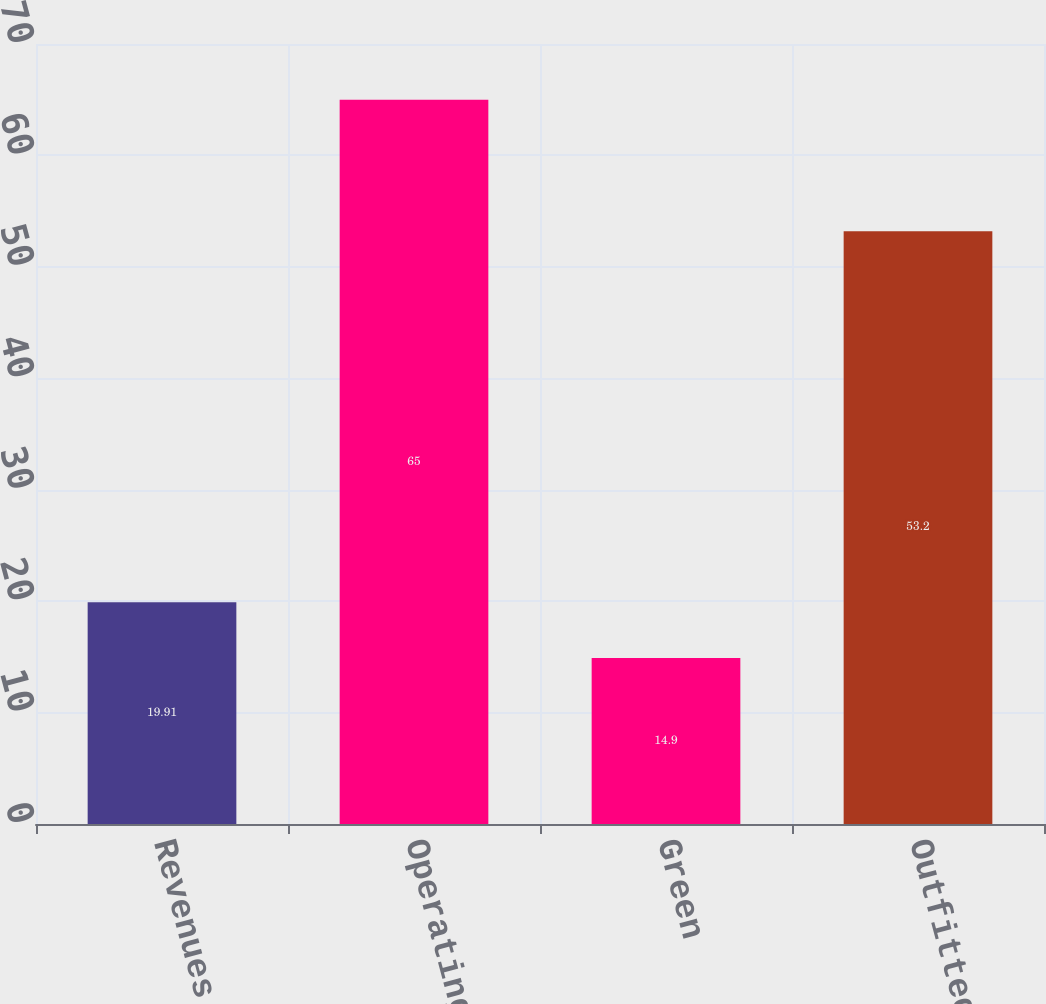<chart> <loc_0><loc_0><loc_500><loc_500><bar_chart><fcel>Revenues<fcel>Operating earnings<fcel>Green<fcel>Outfitted<nl><fcel>19.91<fcel>65<fcel>14.9<fcel>53.2<nl></chart> 